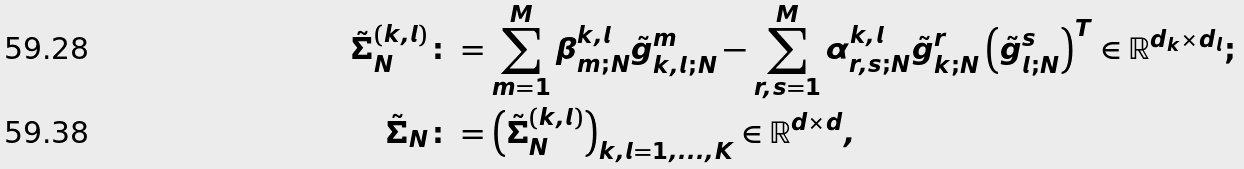<formula> <loc_0><loc_0><loc_500><loc_500>\tilde { \varSigma } ^ { ( k , l ) } _ { N } & \colon = \sum _ { m = 1 } ^ { M } \beta _ { m ; N } ^ { k , l } \tilde { g } _ { k , l ; N } ^ { m } - \sum _ { r , s = 1 } ^ { M } \alpha _ { r , s ; N } ^ { k , l } \tilde { g } _ { k ; N } ^ { r } \left ( \tilde { g } _ { l ; N } ^ { s } \right ) ^ { T } \in \mathbb { R } ^ { d _ { k } \times d _ { l } } ; \\ \tilde { \varSigma } _ { N } & \colon = \left ( \tilde { \varSigma } _ { N } ^ { ( k , l ) } \right ) _ { k , l = 1 , \dots , K } \in \mathbb { R } ^ { d \times d } ,</formula> 